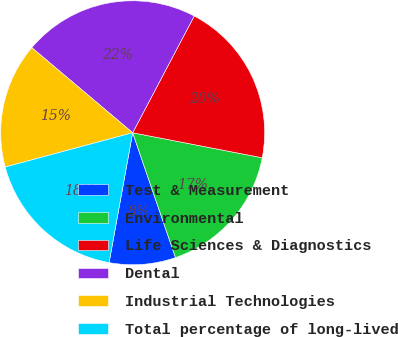Convert chart. <chart><loc_0><loc_0><loc_500><loc_500><pie_chart><fcel>Test & Measurement<fcel>Environmental<fcel>Life Sciences & Diagnostics<fcel>Dental<fcel>Industrial Technologies<fcel>Total percentage of long-lived<nl><fcel>8.12%<fcel>16.7%<fcel>20.31%<fcel>21.57%<fcel>15.34%<fcel>17.96%<nl></chart> 